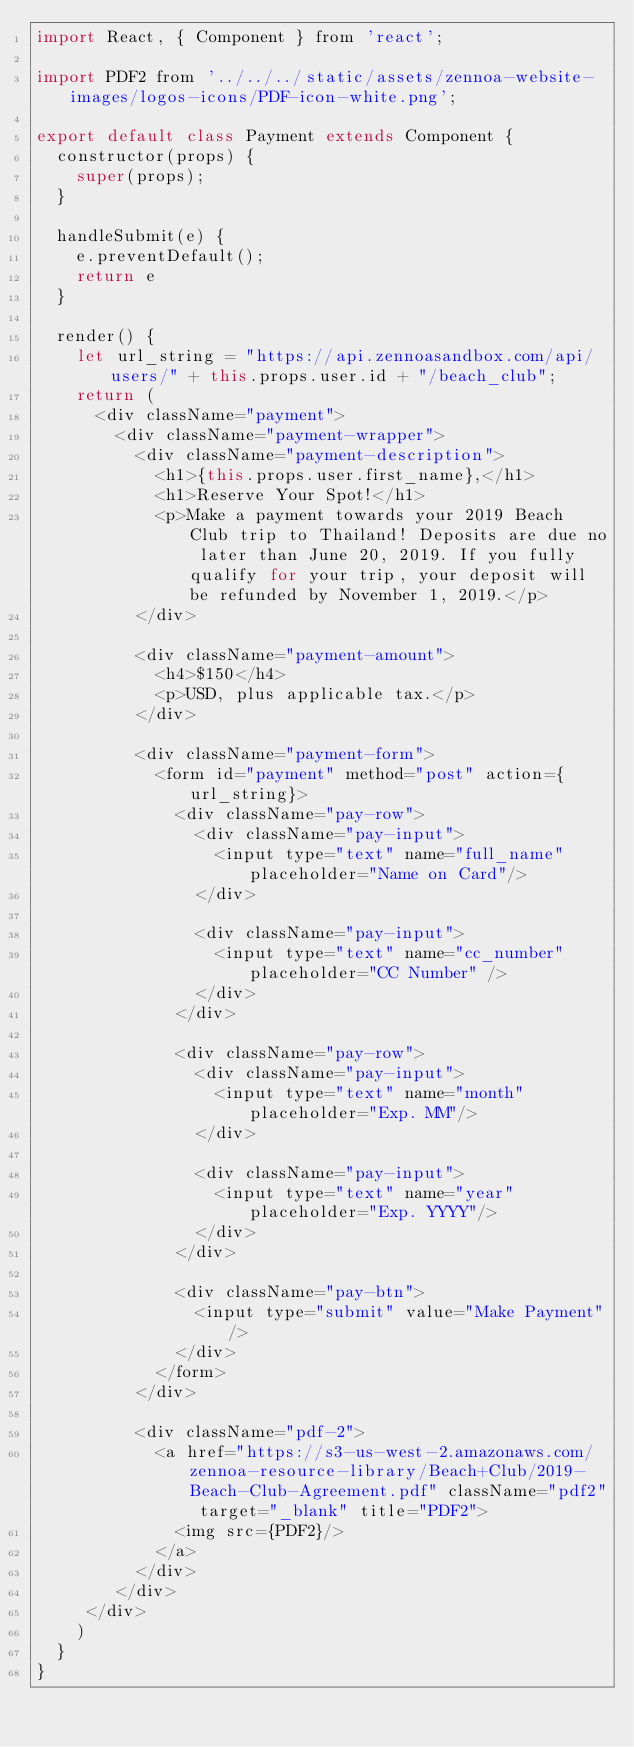Convert code to text. <code><loc_0><loc_0><loc_500><loc_500><_JavaScript_>import React, { Component } from 'react';

import PDF2 from '../../../static/assets/zennoa-website-images/logos-icons/PDF-icon-white.png';

export default class Payment extends Component {
  constructor(props) {
    super(props);
  }

  handleSubmit(e) {
    e.preventDefault();
    return e
  }

  render() {
    let url_string = "https://api.zennoasandbox.com/api/users/" + this.props.user.id + "/beach_club";
    return (
      <div className="payment">
        <div className="payment-wrapper">
          <div className="payment-description">
            <h1>{this.props.user.first_name},</h1>
            <h1>Reserve Your Spot!</h1>
            <p>Make a payment towards your 2019 Beach Club trip to Thailand! Deposits are due no later than June 20, 2019. If you fully qualify for your trip, your deposit will be refunded by November 1, 2019.</p>
          </div>

          <div className="payment-amount">
            <h4>$150</h4>
            <p>USD, plus applicable tax.</p>
          </div>
          
          <div className="payment-form">
            <form id="payment" method="post" action={url_string}>
              <div className="pay-row">
                <div className="pay-input">
                  <input type="text" name="full_name" placeholder="Name on Card"/>
                </div>

                <div className="pay-input">
                  <input type="text" name="cc_number" placeholder="CC Number" />
                </div>
              </div>
              
              <div className="pay-row">
                <div className="pay-input">
                  <input type="text" name="month" placeholder="Exp. MM"/>
                </div>

                <div className="pay-input">
                  <input type="text" name="year" placeholder="Exp. YYYY"/>
                </div>
              </div>

              <div className="pay-btn">
                <input type="submit" value="Make Payment"/>
              </div>
            </form> 
          </div>
          
          <div className="pdf-2">
            <a href="https://s3-us-west-2.amazonaws.com/zennoa-resource-library/Beach+Club/2019-Beach-Club-Agreement.pdf" className="pdf2" target="_blank" title="PDF2">
              <img src={PDF2}/>
            </a>
          </div>
        </div>
     </div>
    )
  }
}</code> 